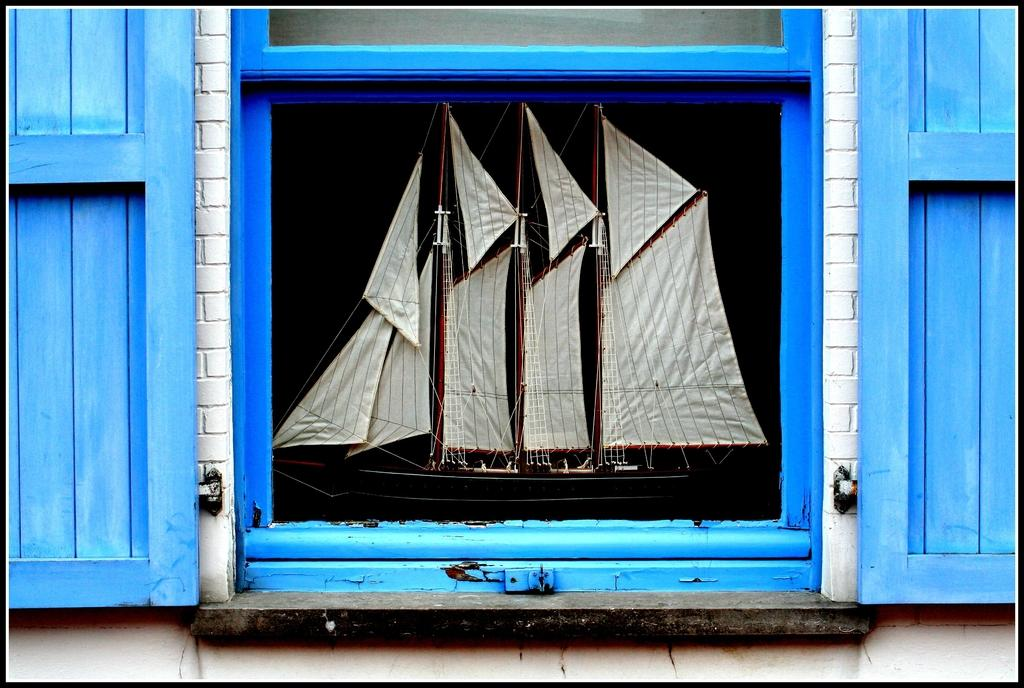What can be seen through the window in the image? A boat is visible through the window in the image. What part of the window is mentioned in the facts? The doors of the window are blue in color. Can you describe the window in the image? There is a window with blue doors in the image. How many frogs are sitting on the toes of the people in the image? There are no people or frogs present in the image, so this question cannot be answered. 